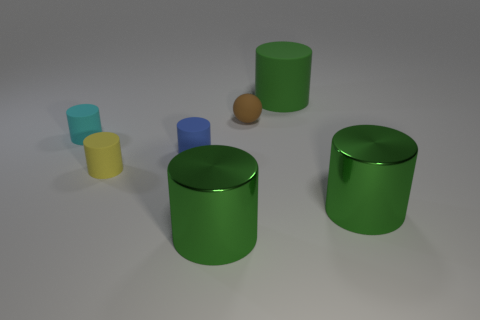What size is the blue cylinder that is the same material as the tiny yellow cylinder?
Offer a terse response. Small. What number of large shiny things are the same color as the big rubber cylinder?
Provide a succinct answer. 2. Is the number of small yellow things in front of the tiny blue cylinder less than the number of cylinders to the right of the small brown object?
Offer a very short reply. Yes. Does the large object that is behind the tiny cyan rubber object have the same shape as the yellow rubber thing?
Make the answer very short. Yes. Do the large green object behind the cyan rubber object and the tiny yellow thing have the same material?
Your answer should be very brief. Yes. The big object in front of the object that is right of the green cylinder that is behind the small blue object is made of what material?
Your answer should be very brief. Metal. What number of other things are there of the same shape as the cyan matte object?
Provide a succinct answer. 5. The large object behind the cyan thing is what color?
Provide a succinct answer. Green. What number of green rubber cylinders are left of the tiny object that is behind the small rubber thing that is to the left of the yellow thing?
Keep it short and to the point. 0. There is a small cylinder behind the blue thing; how many green matte objects are to the left of it?
Offer a terse response. 0. 